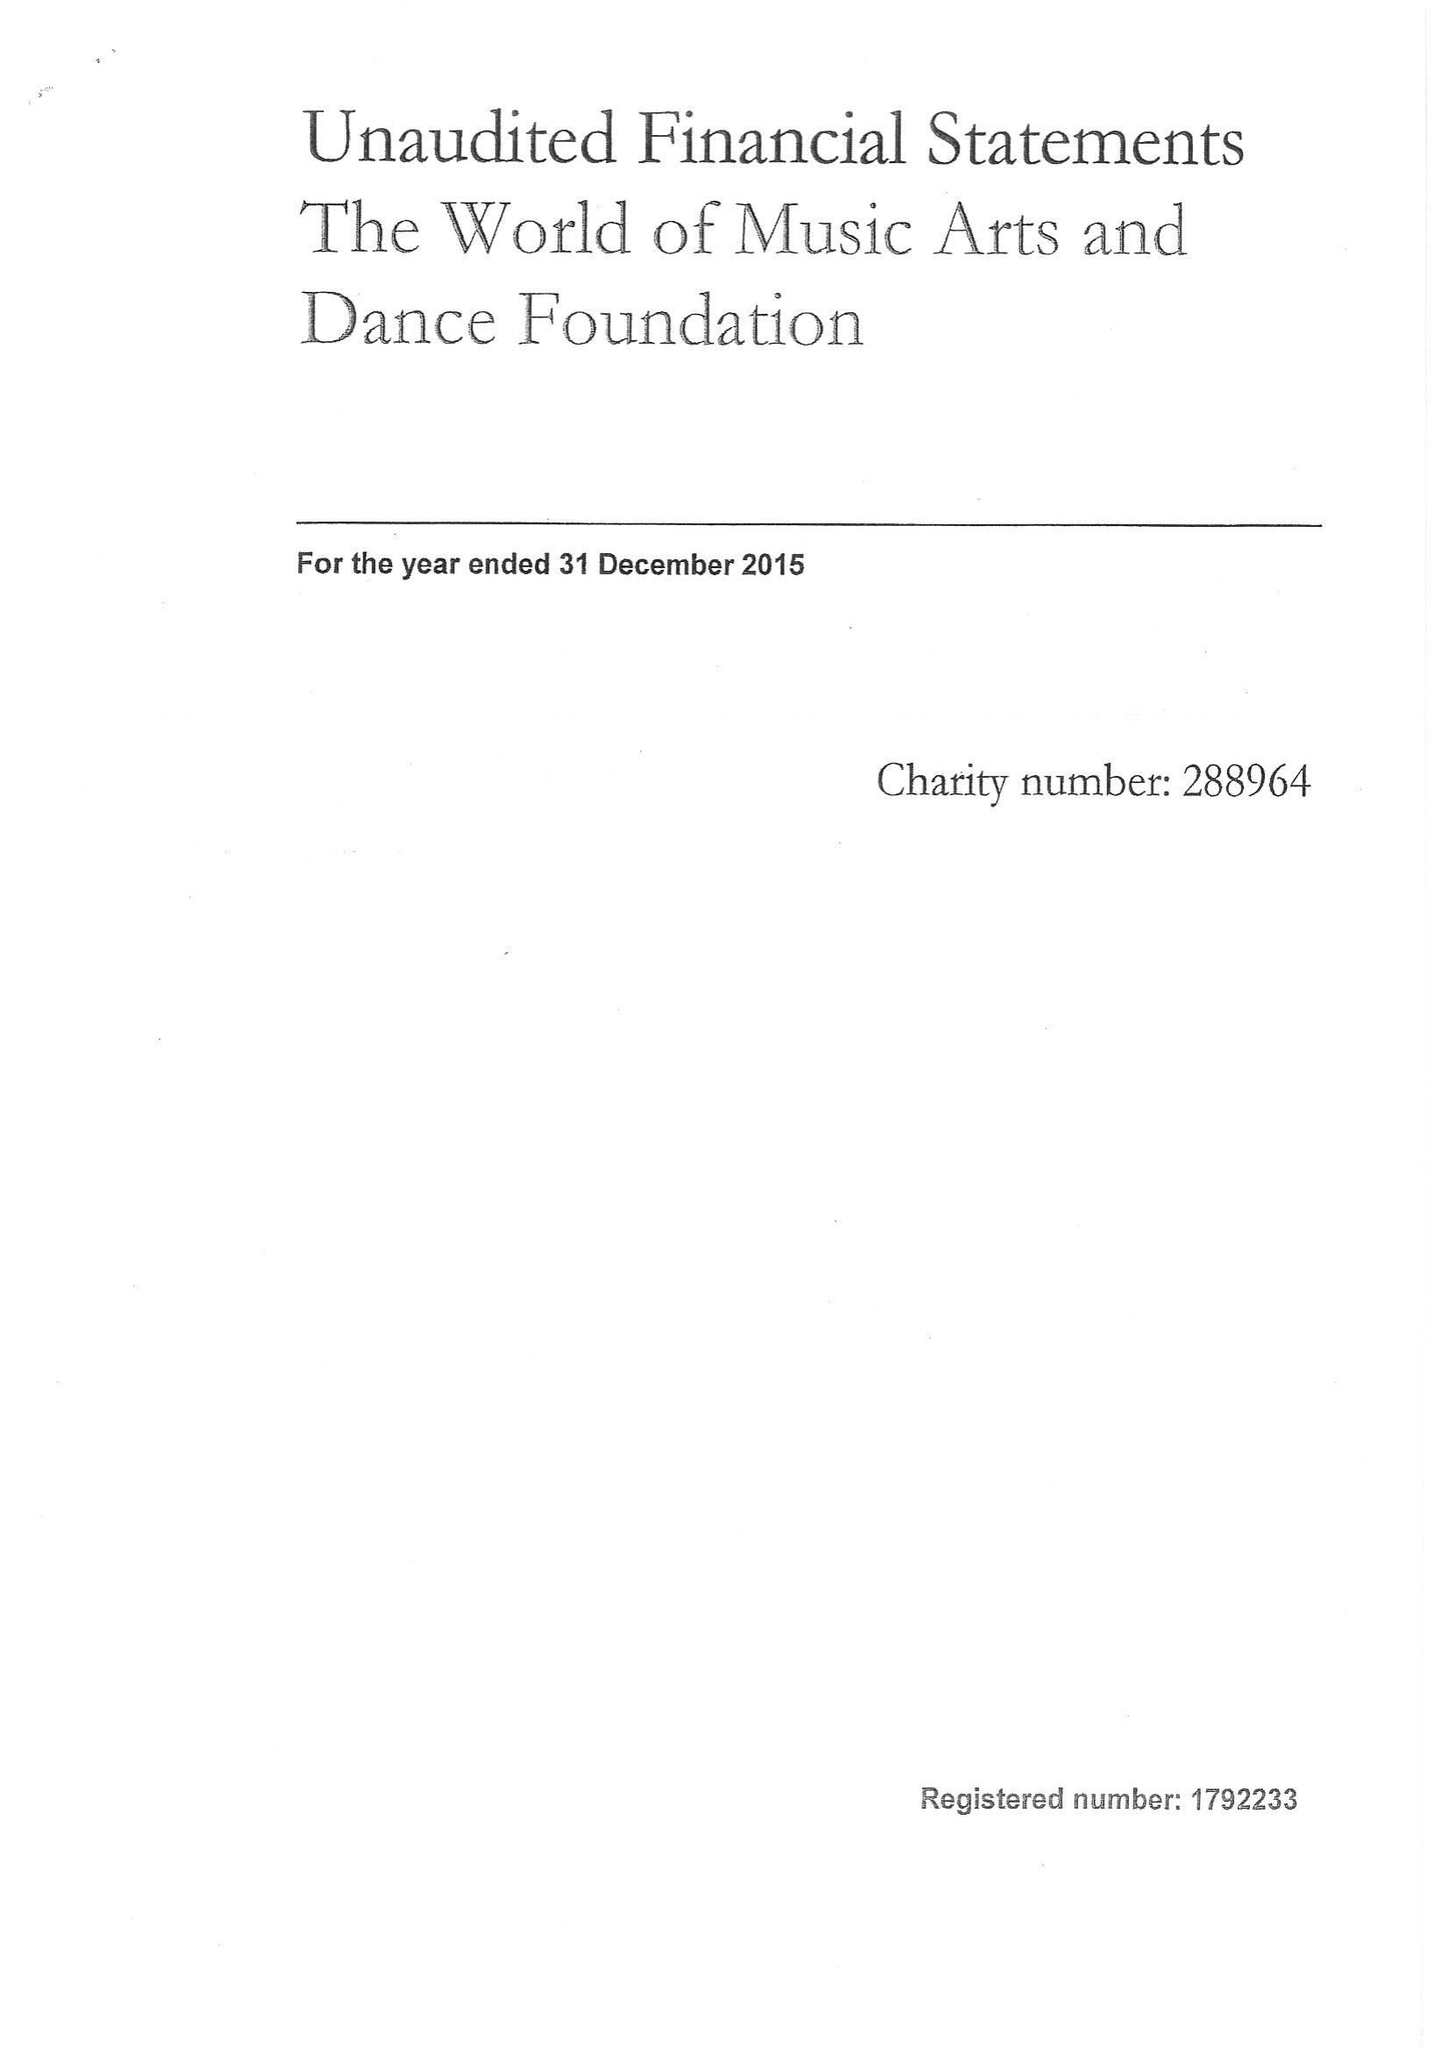What is the value for the charity_number?
Answer the question using a single word or phrase. 288964 